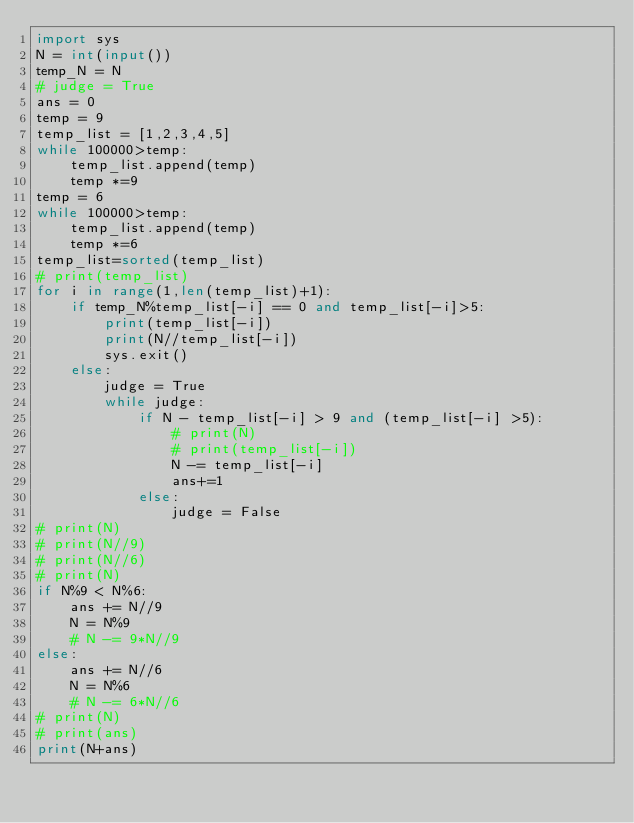Convert code to text. <code><loc_0><loc_0><loc_500><loc_500><_Python_>import sys
N = int(input())
temp_N = N
# judge = True
ans = 0
temp = 9
temp_list = [1,2,3,4,5]
while 100000>temp:
    temp_list.append(temp)
    temp *=9 
temp = 6
while 100000>temp:
    temp_list.append(temp)
    temp *=6 
temp_list=sorted(temp_list)
# print(temp_list)
for i in range(1,len(temp_list)+1):
    if temp_N%temp_list[-i] == 0 and temp_list[-i]>5:
        print(temp_list[-i])
        print(N//temp_list[-i])
        sys.exit() 
    else:
        judge = True
        while judge:
            if N - temp_list[-i] > 9 and (temp_list[-i] >5):
                # print(N)
                # print(temp_list[-i])
                N -= temp_list[-i]
                ans+=1
            else:
                judge = False
# print(N)
# print(N//9)
# print(N//6)
# print(N)
if N%9 < N%6:
    ans += N//9
    N = N%9
    # N -= 9*N//9
else:
    ans += N//6
    N = N%6
    # N -= 6*N//6
# print(N)
# print(ans)
print(N+ans)
</code> 